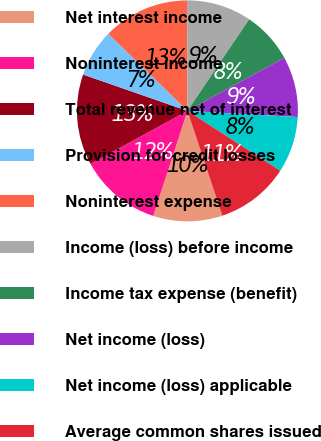<chart> <loc_0><loc_0><loc_500><loc_500><pie_chart><fcel>Net interest income<fcel>Noninterest income<fcel>Total revenue net of interest<fcel>Provision for credit losses<fcel>Noninterest expense<fcel>Income (loss) before income<fcel>Income tax expense (benefit)<fcel>Net income (loss)<fcel>Net income (loss) applicable<fcel>Average common shares issued<nl><fcel>10.13%<fcel>12.03%<fcel>13.29%<fcel>6.96%<fcel>12.66%<fcel>9.49%<fcel>7.59%<fcel>8.86%<fcel>8.23%<fcel>10.76%<nl></chart> 